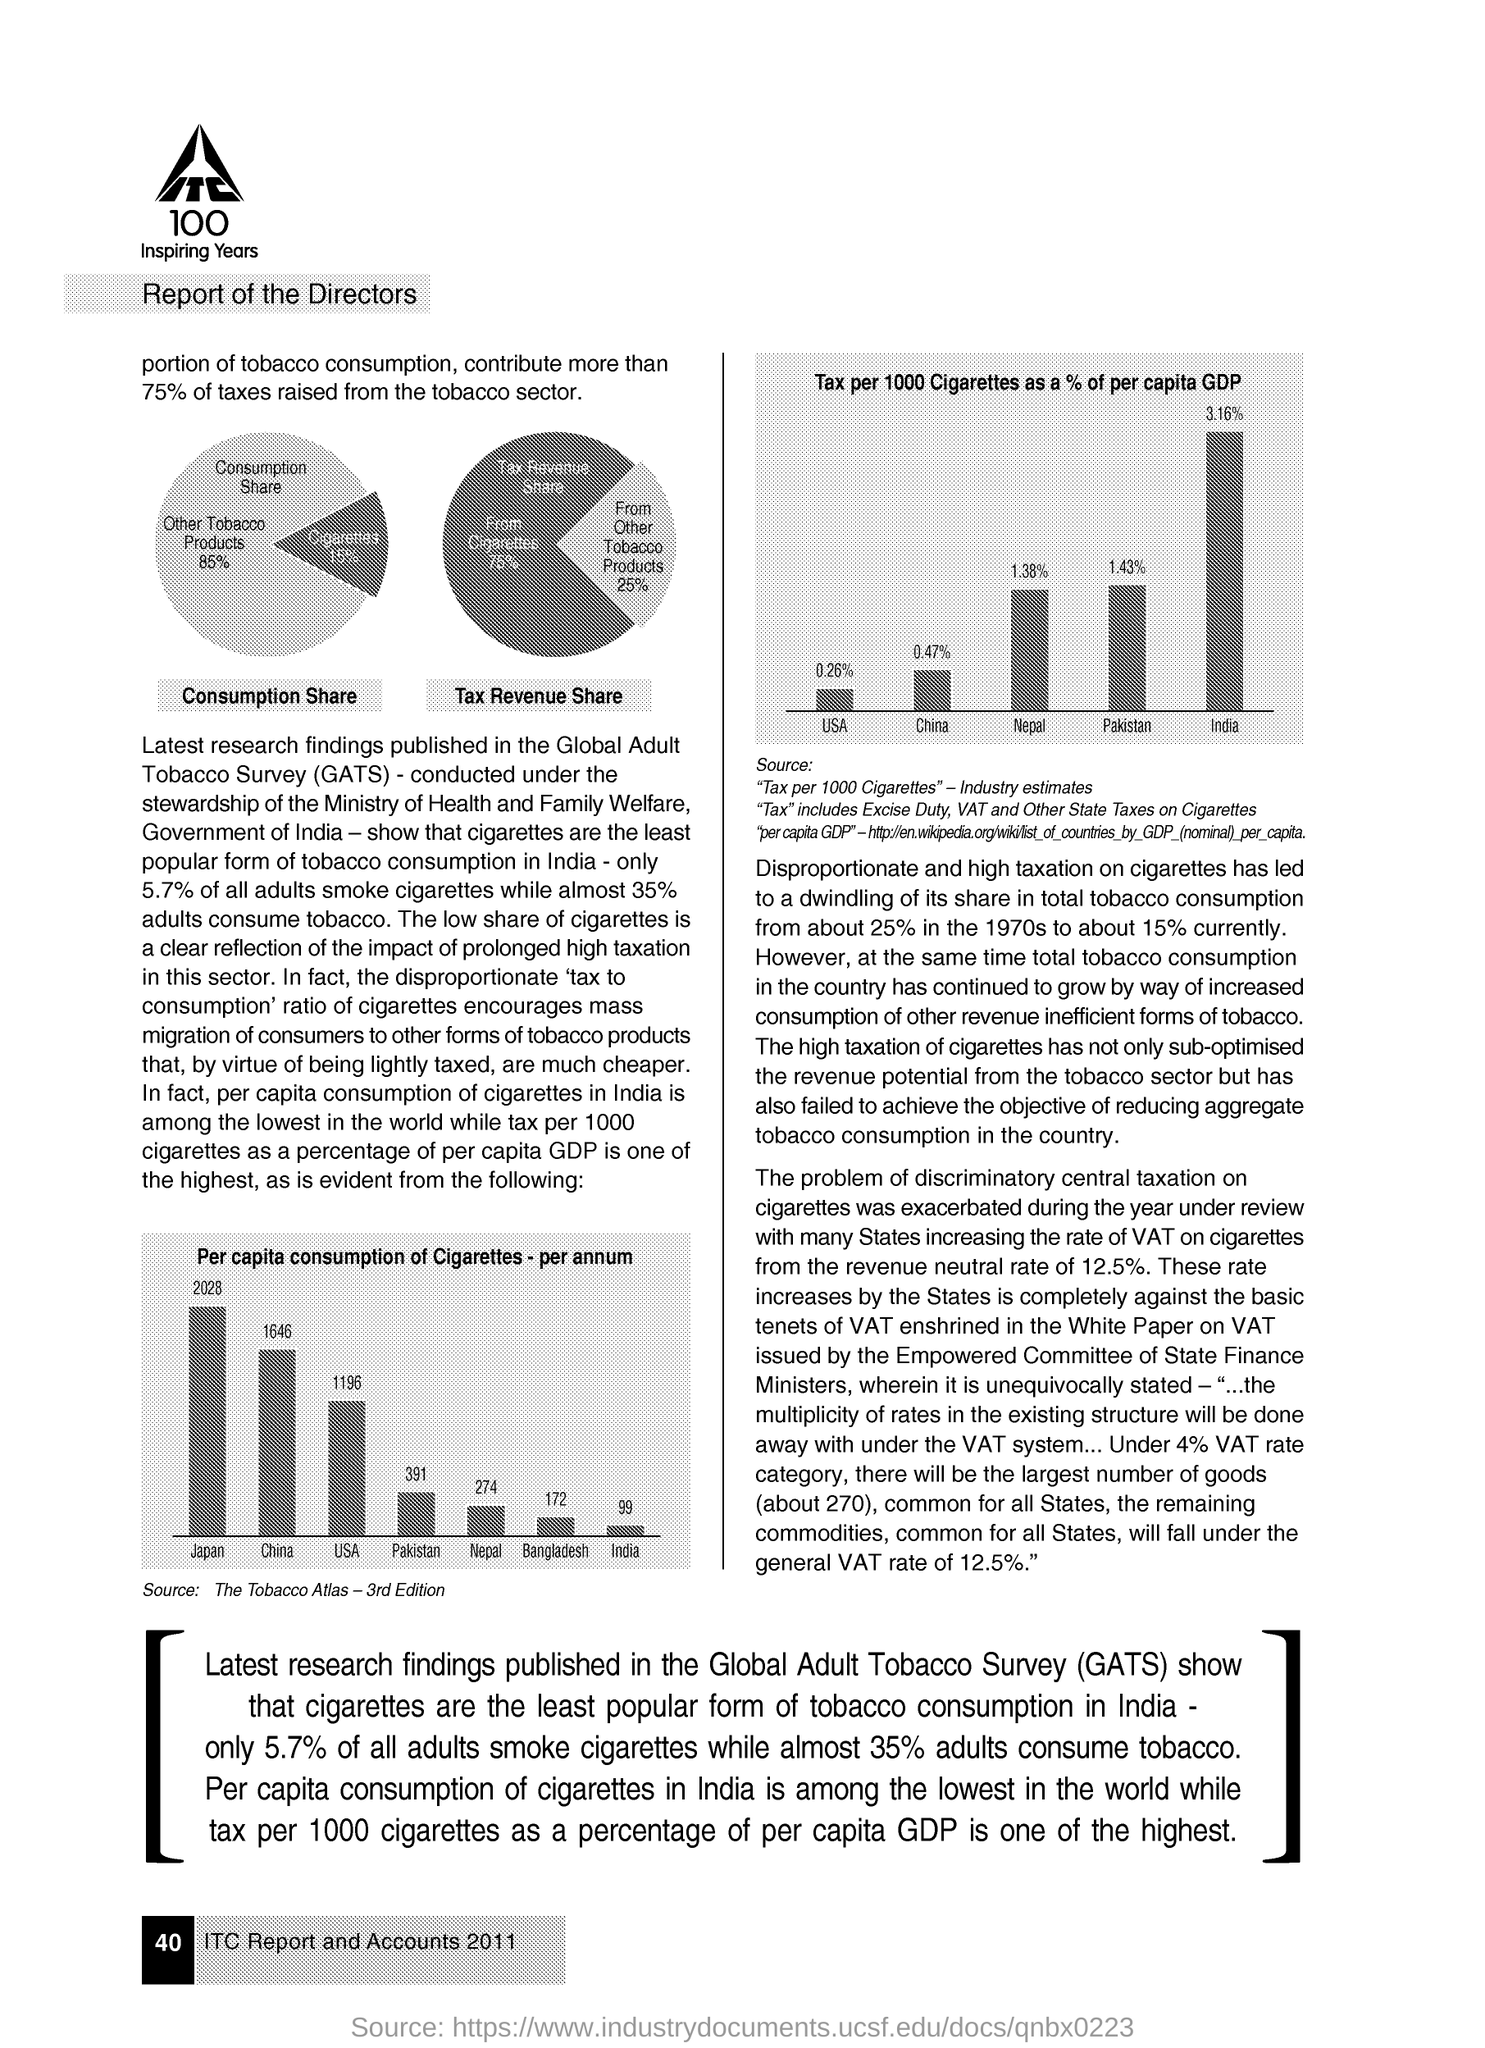What is the Fullform of GATS ?
Offer a terse response. Global Adult Tobacco Survey. 